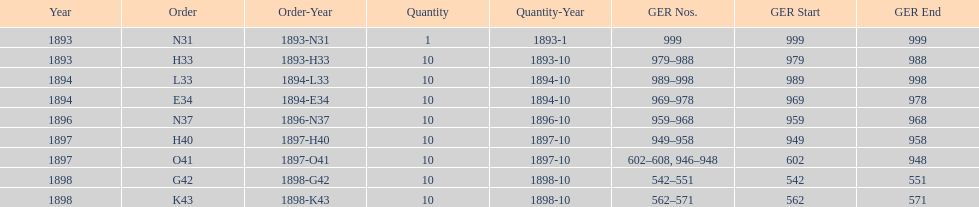What amount of time to the years span? 5 years. 